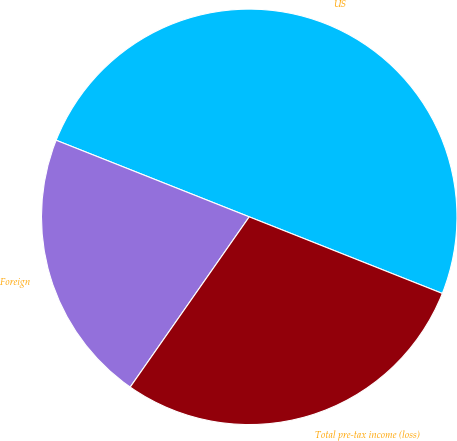Convert chart to OTSL. <chart><loc_0><loc_0><loc_500><loc_500><pie_chart><fcel>US<fcel>Foreign<fcel>Total pre-tax income (loss)<nl><fcel>50.0%<fcel>21.3%<fcel>28.7%<nl></chart> 